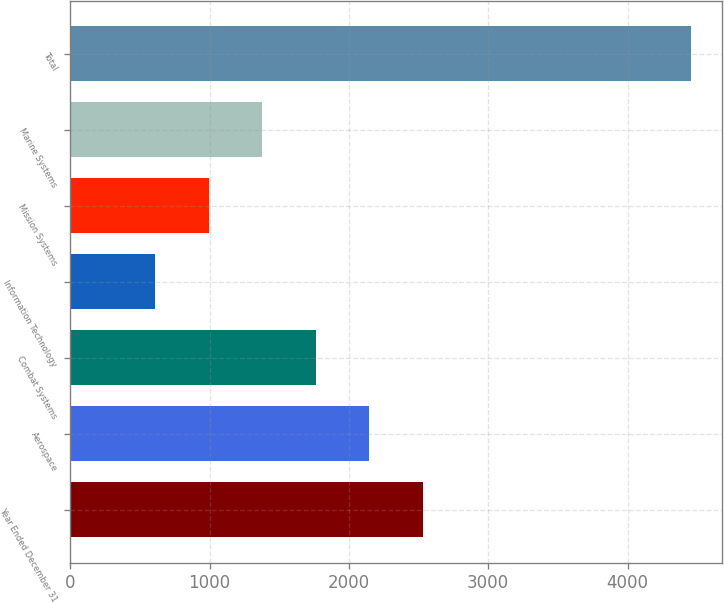Convert chart to OTSL. <chart><loc_0><loc_0><loc_500><loc_500><bar_chart><fcel>Year Ended December 31<fcel>Aerospace<fcel>Combat Systems<fcel>Information Technology<fcel>Mission Systems<fcel>Marine Systems<fcel>Total<nl><fcel>2532.5<fcel>2147.6<fcel>1762.7<fcel>608<fcel>992.9<fcel>1377.8<fcel>4457<nl></chart> 